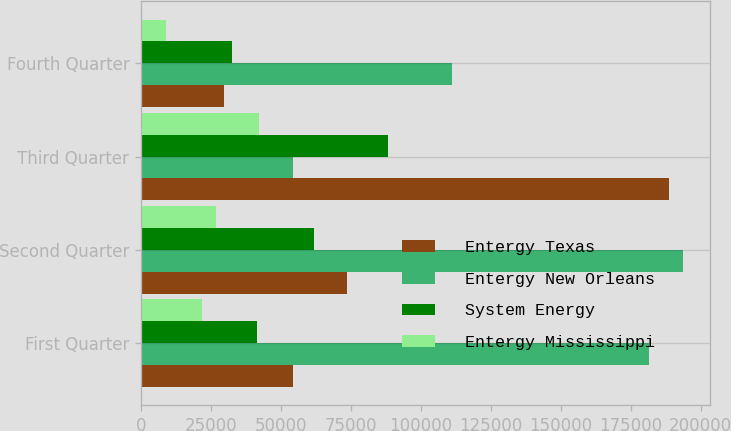Convert chart. <chart><loc_0><loc_0><loc_500><loc_500><stacked_bar_chart><ecel><fcel>First Quarter<fcel>Second Quarter<fcel>Third Quarter<fcel>Fourth Quarter<nl><fcel>Entergy Texas<fcel>54378<fcel>73447<fcel>188660<fcel>29843<nl><fcel>Entergy New Orleans<fcel>181618<fcel>193752<fcel>54378<fcel>111066<nl><fcel>System Energy<fcel>41573<fcel>61890<fcel>88312<fcel>32464<nl><fcel>Entergy Mississippi<fcel>21880<fcel>26913<fcel>42279<fcel>8807<nl></chart> 